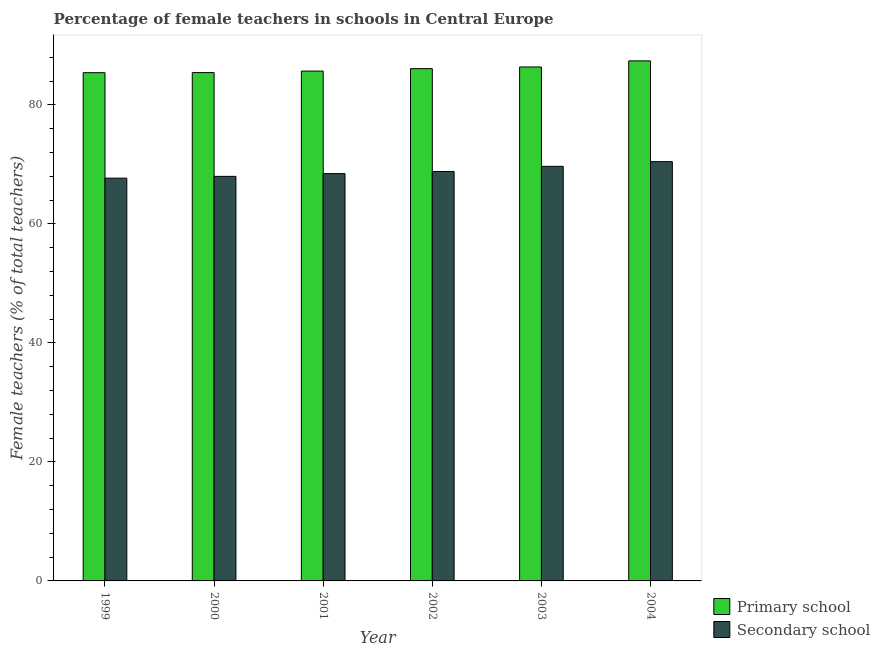How many groups of bars are there?
Your answer should be very brief. 6. Are the number of bars on each tick of the X-axis equal?
Your answer should be compact. Yes. What is the label of the 4th group of bars from the left?
Ensure brevity in your answer.  2002. In how many cases, is the number of bars for a given year not equal to the number of legend labels?
Your answer should be very brief. 0. What is the percentage of female teachers in secondary schools in 1999?
Provide a succinct answer. 67.7. Across all years, what is the maximum percentage of female teachers in primary schools?
Your answer should be compact. 87.41. Across all years, what is the minimum percentage of female teachers in secondary schools?
Offer a very short reply. 67.7. In which year was the percentage of female teachers in primary schools minimum?
Your answer should be very brief. 1999. What is the total percentage of female teachers in primary schools in the graph?
Provide a succinct answer. 516.46. What is the difference between the percentage of female teachers in primary schools in 2001 and that in 2004?
Provide a succinct answer. -1.72. What is the difference between the percentage of female teachers in secondary schools in 2003 and the percentage of female teachers in primary schools in 1999?
Offer a terse response. 1.98. What is the average percentage of female teachers in primary schools per year?
Keep it short and to the point. 86.08. What is the ratio of the percentage of female teachers in secondary schools in 2001 to that in 2003?
Provide a succinct answer. 0.98. Is the percentage of female teachers in secondary schools in 2002 less than that in 2004?
Ensure brevity in your answer.  Yes. What is the difference between the highest and the second highest percentage of female teachers in secondary schools?
Offer a very short reply. 0.79. What is the difference between the highest and the lowest percentage of female teachers in secondary schools?
Provide a succinct answer. 2.77. What does the 1st bar from the left in 1999 represents?
Ensure brevity in your answer.  Primary school. What does the 2nd bar from the right in 2001 represents?
Ensure brevity in your answer.  Primary school. How many bars are there?
Offer a terse response. 12. Are all the bars in the graph horizontal?
Make the answer very short. No. Does the graph contain any zero values?
Your response must be concise. No. How many legend labels are there?
Make the answer very short. 2. What is the title of the graph?
Provide a succinct answer. Percentage of female teachers in schools in Central Europe. Does "Rural Population" appear as one of the legend labels in the graph?
Offer a terse response. No. What is the label or title of the Y-axis?
Give a very brief answer. Female teachers (% of total teachers). What is the Female teachers (% of total teachers) in Primary school in 1999?
Offer a terse response. 85.43. What is the Female teachers (% of total teachers) in Secondary school in 1999?
Keep it short and to the point. 67.7. What is the Female teachers (% of total teachers) of Primary school in 2000?
Keep it short and to the point. 85.44. What is the Female teachers (% of total teachers) in Secondary school in 2000?
Your answer should be very brief. 68. What is the Female teachers (% of total teachers) in Primary school in 2001?
Provide a short and direct response. 85.69. What is the Female teachers (% of total teachers) of Secondary school in 2001?
Offer a very short reply. 68.46. What is the Female teachers (% of total teachers) in Primary school in 2002?
Offer a very short reply. 86.1. What is the Female teachers (% of total teachers) of Secondary school in 2002?
Offer a very short reply. 68.82. What is the Female teachers (% of total teachers) of Primary school in 2003?
Keep it short and to the point. 86.39. What is the Female teachers (% of total teachers) of Secondary school in 2003?
Offer a terse response. 69.68. What is the Female teachers (% of total teachers) of Primary school in 2004?
Provide a succinct answer. 87.41. What is the Female teachers (% of total teachers) in Secondary school in 2004?
Provide a succinct answer. 70.47. Across all years, what is the maximum Female teachers (% of total teachers) in Primary school?
Offer a terse response. 87.41. Across all years, what is the maximum Female teachers (% of total teachers) of Secondary school?
Your response must be concise. 70.47. Across all years, what is the minimum Female teachers (% of total teachers) in Primary school?
Your answer should be compact. 85.43. Across all years, what is the minimum Female teachers (% of total teachers) in Secondary school?
Provide a succinct answer. 67.7. What is the total Female teachers (% of total teachers) in Primary school in the graph?
Offer a terse response. 516.46. What is the total Female teachers (% of total teachers) of Secondary school in the graph?
Offer a very short reply. 413.14. What is the difference between the Female teachers (% of total teachers) in Primary school in 1999 and that in 2000?
Offer a terse response. -0.01. What is the difference between the Female teachers (% of total teachers) of Secondary school in 1999 and that in 2000?
Provide a short and direct response. -0.3. What is the difference between the Female teachers (% of total teachers) of Primary school in 1999 and that in 2001?
Offer a terse response. -0.27. What is the difference between the Female teachers (% of total teachers) in Secondary school in 1999 and that in 2001?
Keep it short and to the point. -0.76. What is the difference between the Female teachers (% of total teachers) in Primary school in 1999 and that in 2002?
Offer a terse response. -0.68. What is the difference between the Female teachers (% of total teachers) in Secondary school in 1999 and that in 2002?
Keep it short and to the point. -1.12. What is the difference between the Female teachers (% of total teachers) of Primary school in 1999 and that in 2003?
Keep it short and to the point. -0.96. What is the difference between the Female teachers (% of total teachers) of Secondary school in 1999 and that in 2003?
Offer a very short reply. -1.98. What is the difference between the Female teachers (% of total teachers) in Primary school in 1999 and that in 2004?
Offer a terse response. -1.98. What is the difference between the Female teachers (% of total teachers) of Secondary school in 1999 and that in 2004?
Offer a terse response. -2.77. What is the difference between the Female teachers (% of total teachers) in Primary school in 2000 and that in 2001?
Your response must be concise. -0.25. What is the difference between the Female teachers (% of total teachers) of Secondary school in 2000 and that in 2001?
Give a very brief answer. -0.46. What is the difference between the Female teachers (% of total teachers) in Primary school in 2000 and that in 2002?
Your answer should be very brief. -0.66. What is the difference between the Female teachers (% of total teachers) of Secondary school in 2000 and that in 2002?
Give a very brief answer. -0.82. What is the difference between the Female teachers (% of total teachers) in Primary school in 2000 and that in 2003?
Your answer should be very brief. -0.95. What is the difference between the Female teachers (% of total teachers) of Secondary school in 2000 and that in 2003?
Offer a very short reply. -1.68. What is the difference between the Female teachers (% of total teachers) of Primary school in 2000 and that in 2004?
Provide a short and direct response. -1.97. What is the difference between the Female teachers (% of total teachers) of Secondary school in 2000 and that in 2004?
Your response must be concise. -2.47. What is the difference between the Female teachers (% of total teachers) of Primary school in 2001 and that in 2002?
Ensure brevity in your answer.  -0.41. What is the difference between the Female teachers (% of total teachers) in Secondary school in 2001 and that in 2002?
Give a very brief answer. -0.36. What is the difference between the Female teachers (% of total teachers) of Primary school in 2001 and that in 2003?
Provide a succinct answer. -0.69. What is the difference between the Female teachers (% of total teachers) in Secondary school in 2001 and that in 2003?
Provide a short and direct response. -1.22. What is the difference between the Female teachers (% of total teachers) of Primary school in 2001 and that in 2004?
Ensure brevity in your answer.  -1.72. What is the difference between the Female teachers (% of total teachers) in Secondary school in 2001 and that in 2004?
Offer a very short reply. -2.01. What is the difference between the Female teachers (% of total teachers) of Primary school in 2002 and that in 2003?
Your answer should be compact. -0.28. What is the difference between the Female teachers (% of total teachers) in Secondary school in 2002 and that in 2003?
Your answer should be very brief. -0.86. What is the difference between the Female teachers (% of total teachers) in Primary school in 2002 and that in 2004?
Your response must be concise. -1.31. What is the difference between the Female teachers (% of total teachers) of Secondary school in 2002 and that in 2004?
Keep it short and to the point. -1.66. What is the difference between the Female teachers (% of total teachers) of Primary school in 2003 and that in 2004?
Ensure brevity in your answer.  -1.02. What is the difference between the Female teachers (% of total teachers) in Secondary school in 2003 and that in 2004?
Your response must be concise. -0.79. What is the difference between the Female teachers (% of total teachers) in Primary school in 1999 and the Female teachers (% of total teachers) in Secondary school in 2000?
Your answer should be very brief. 17.43. What is the difference between the Female teachers (% of total teachers) in Primary school in 1999 and the Female teachers (% of total teachers) in Secondary school in 2001?
Offer a very short reply. 16.96. What is the difference between the Female teachers (% of total teachers) of Primary school in 1999 and the Female teachers (% of total teachers) of Secondary school in 2002?
Ensure brevity in your answer.  16.61. What is the difference between the Female teachers (% of total teachers) in Primary school in 1999 and the Female teachers (% of total teachers) in Secondary school in 2003?
Offer a terse response. 15.74. What is the difference between the Female teachers (% of total teachers) of Primary school in 1999 and the Female teachers (% of total teachers) of Secondary school in 2004?
Ensure brevity in your answer.  14.95. What is the difference between the Female teachers (% of total teachers) in Primary school in 2000 and the Female teachers (% of total teachers) in Secondary school in 2001?
Your answer should be compact. 16.98. What is the difference between the Female teachers (% of total teachers) in Primary school in 2000 and the Female teachers (% of total teachers) in Secondary school in 2002?
Provide a short and direct response. 16.62. What is the difference between the Female teachers (% of total teachers) of Primary school in 2000 and the Female teachers (% of total teachers) of Secondary school in 2003?
Make the answer very short. 15.76. What is the difference between the Female teachers (% of total teachers) in Primary school in 2000 and the Female teachers (% of total teachers) in Secondary school in 2004?
Provide a succinct answer. 14.97. What is the difference between the Female teachers (% of total teachers) of Primary school in 2001 and the Female teachers (% of total teachers) of Secondary school in 2002?
Give a very brief answer. 16.88. What is the difference between the Female teachers (% of total teachers) in Primary school in 2001 and the Female teachers (% of total teachers) in Secondary school in 2003?
Give a very brief answer. 16.01. What is the difference between the Female teachers (% of total teachers) of Primary school in 2001 and the Female teachers (% of total teachers) of Secondary school in 2004?
Give a very brief answer. 15.22. What is the difference between the Female teachers (% of total teachers) of Primary school in 2002 and the Female teachers (% of total teachers) of Secondary school in 2003?
Ensure brevity in your answer.  16.42. What is the difference between the Female teachers (% of total teachers) in Primary school in 2002 and the Female teachers (% of total teachers) in Secondary school in 2004?
Keep it short and to the point. 15.63. What is the difference between the Female teachers (% of total teachers) of Primary school in 2003 and the Female teachers (% of total teachers) of Secondary school in 2004?
Provide a short and direct response. 15.91. What is the average Female teachers (% of total teachers) in Primary school per year?
Offer a very short reply. 86.08. What is the average Female teachers (% of total teachers) in Secondary school per year?
Keep it short and to the point. 68.86. In the year 1999, what is the difference between the Female teachers (% of total teachers) in Primary school and Female teachers (% of total teachers) in Secondary school?
Offer a terse response. 17.73. In the year 2000, what is the difference between the Female teachers (% of total teachers) in Primary school and Female teachers (% of total teachers) in Secondary school?
Provide a succinct answer. 17.44. In the year 2001, what is the difference between the Female teachers (% of total teachers) of Primary school and Female teachers (% of total teachers) of Secondary school?
Provide a succinct answer. 17.23. In the year 2002, what is the difference between the Female teachers (% of total teachers) in Primary school and Female teachers (% of total teachers) in Secondary school?
Offer a very short reply. 17.28. In the year 2003, what is the difference between the Female teachers (% of total teachers) of Primary school and Female teachers (% of total teachers) of Secondary school?
Make the answer very short. 16.7. In the year 2004, what is the difference between the Female teachers (% of total teachers) in Primary school and Female teachers (% of total teachers) in Secondary school?
Offer a terse response. 16.94. What is the ratio of the Female teachers (% of total teachers) of Secondary school in 1999 to that in 2000?
Give a very brief answer. 1. What is the ratio of the Female teachers (% of total teachers) of Secondary school in 1999 to that in 2001?
Offer a very short reply. 0.99. What is the ratio of the Female teachers (% of total teachers) in Secondary school in 1999 to that in 2002?
Your response must be concise. 0.98. What is the ratio of the Female teachers (% of total teachers) in Primary school in 1999 to that in 2003?
Offer a very short reply. 0.99. What is the ratio of the Female teachers (% of total teachers) in Secondary school in 1999 to that in 2003?
Ensure brevity in your answer.  0.97. What is the ratio of the Female teachers (% of total teachers) of Primary school in 1999 to that in 2004?
Provide a short and direct response. 0.98. What is the ratio of the Female teachers (% of total teachers) in Secondary school in 1999 to that in 2004?
Make the answer very short. 0.96. What is the ratio of the Female teachers (% of total teachers) of Primary school in 2000 to that in 2001?
Keep it short and to the point. 1. What is the ratio of the Female teachers (% of total teachers) in Secondary school in 2000 to that in 2002?
Your answer should be very brief. 0.99. What is the ratio of the Female teachers (% of total teachers) in Secondary school in 2000 to that in 2003?
Offer a terse response. 0.98. What is the ratio of the Female teachers (% of total teachers) of Primary school in 2000 to that in 2004?
Your answer should be compact. 0.98. What is the ratio of the Female teachers (% of total teachers) in Secondary school in 2000 to that in 2004?
Your answer should be very brief. 0.96. What is the ratio of the Female teachers (% of total teachers) in Primary school in 2001 to that in 2003?
Your response must be concise. 0.99. What is the ratio of the Female teachers (% of total teachers) of Secondary school in 2001 to that in 2003?
Offer a very short reply. 0.98. What is the ratio of the Female teachers (% of total teachers) in Primary school in 2001 to that in 2004?
Your answer should be compact. 0.98. What is the ratio of the Female teachers (% of total teachers) of Secondary school in 2001 to that in 2004?
Ensure brevity in your answer.  0.97. What is the ratio of the Female teachers (% of total teachers) in Secondary school in 2002 to that in 2003?
Make the answer very short. 0.99. What is the ratio of the Female teachers (% of total teachers) in Primary school in 2002 to that in 2004?
Ensure brevity in your answer.  0.98. What is the ratio of the Female teachers (% of total teachers) of Secondary school in 2002 to that in 2004?
Give a very brief answer. 0.98. What is the ratio of the Female teachers (% of total teachers) in Primary school in 2003 to that in 2004?
Your answer should be compact. 0.99. What is the ratio of the Female teachers (% of total teachers) in Secondary school in 2003 to that in 2004?
Keep it short and to the point. 0.99. What is the difference between the highest and the second highest Female teachers (% of total teachers) in Primary school?
Provide a succinct answer. 1.02. What is the difference between the highest and the second highest Female teachers (% of total teachers) in Secondary school?
Your answer should be very brief. 0.79. What is the difference between the highest and the lowest Female teachers (% of total teachers) in Primary school?
Your response must be concise. 1.98. What is the difference between the highest and the lowest Female teachers (% of total teachers) in Secondary school?
Provide a succinct answer. 2.77. 